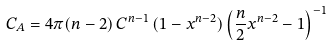Convert formula to latex. <formula><loc_0><loc_0><loc_500><loc_500>C _ { A } = 4 \pi ( n - 2 ) \, C ^ { n - 1 } \, ( 1 - x ^ { n - 2 } ) \left ( \frac { n } { 2 } x ^ { n - 2 } - 1 \right ) ^ { - 1 }</formula> 